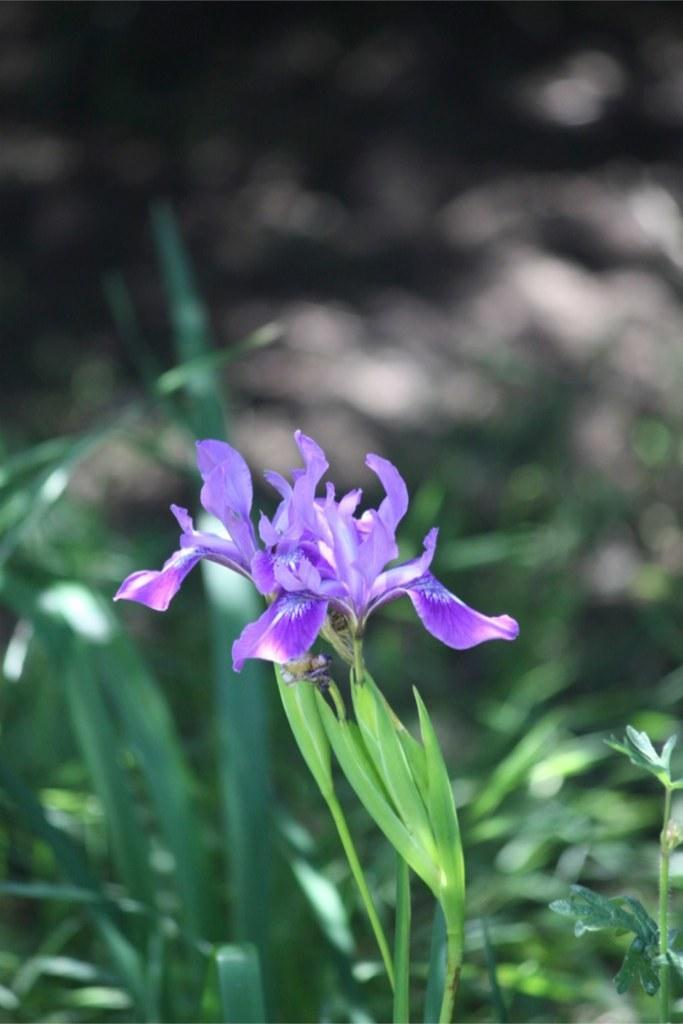How many purple plants are in the image? There are two purple plants in the image. Where are the purple plants located? The purple plants are on a plant stand. What else can be seen in the image besides the purple plants? There are plants in the background of the image. How would you describe the background of the image? The background is blurry. How many servants are attending to the plants in the image? There are no servants present in the image; it only features the plants and the plant stand. 